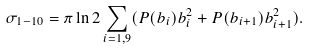Convert formula to latex. <formula><loc_0><loc_0><loc_500><loc_500>\sigma _ { 1 - 1 0 } = \pi \ln { 2 } \sum _ { i = 1 , 9 } ( P ( b _ { i } ) b _ { i } ^ { 2 } + P ( b _ { i + 1 } ) b _ { i + 1 } ^ { 2 } ) .</formula> 